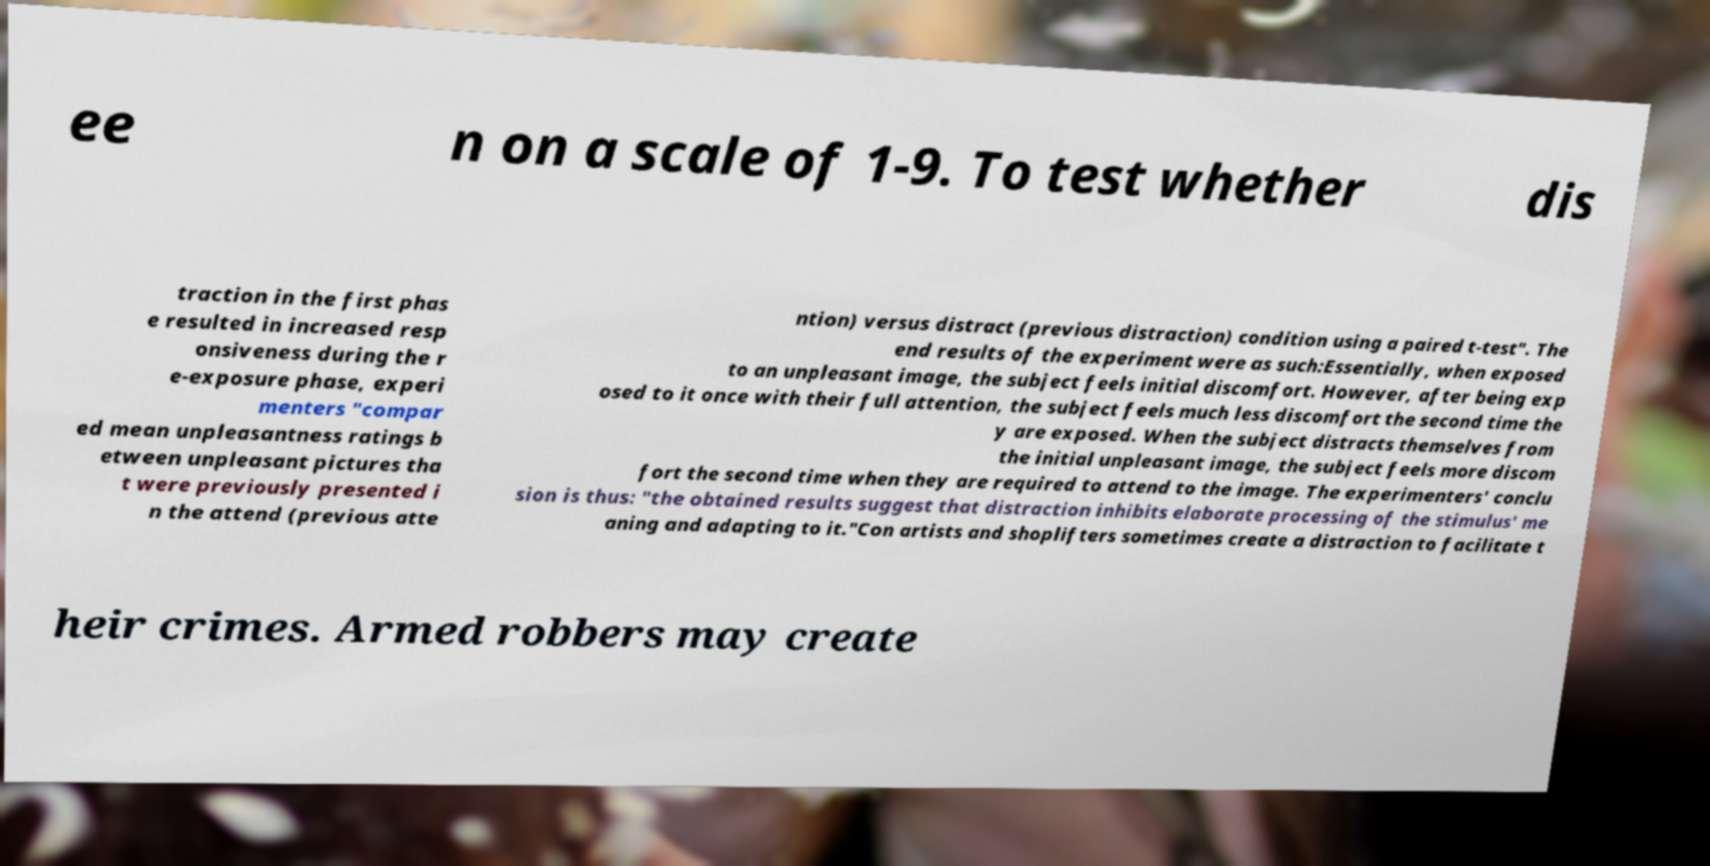Could you extract and type out the text from this image? ee n on a scale of 1-9. To test whether dis traction in the first phas e resulted in increased resp onsiveness during the r e-exposure phase, experi menters "compar ed mean unpleasantness ratings b etween unpleasant pictures tha t were previously presented i n the attend (previous atte ntion) versus distract (previous distraction) condition using a paired t-test". The end results of the experiment were as such:Essentially, when exposed to an unpleasant image, the subject feels initial discomfort. However, after being exp osed to it once with their full attention, the subject feels much less discomfort the second time the y are exposed. When the subject distracts themselves from the initial unpleasant image, the subject feels more discom fort the second time when they are required to attend to the image. The experimenters' conclu sion is thus: "the obtained results suggest that distraction inhibits elaborate processing of the stimulus' me aning and adapting to it."Con artists and shoplifters sometimes create a distraction to facilitate t heir crimes. Armed robbers may create 